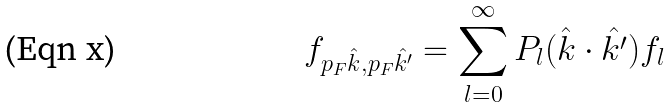<formula> <loc_0><loc_0><loc_500><loc_500>f _ { p _ { F } { \hat { k } } , p _ { F } { \hat { k ^ { \prime } } } } = \sum _ { l = 0 } ^ { \infty } P _ { l } ( { \hat { k } } \cdot { \hat { k ^ { \prime } } } ) f _ { l }</formula> 